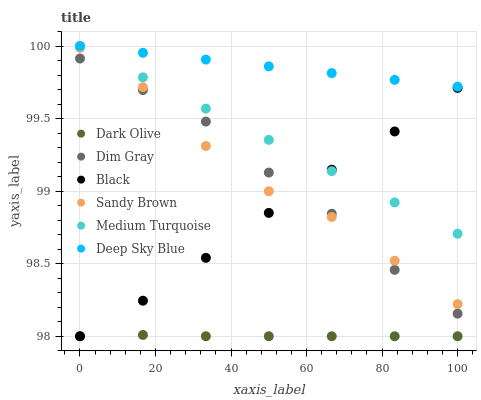Does Dark Olive have the minimum area under the curve?
Answer yes or no. Yes. Does Deep Sky Blue have the maximum area under the curve?
Answer yes or no. Yes. Does Medium Turquoise have the minimum area under the curve?
Answer yes or no. No. Does Medium Turquoise have the maximum area under the curve?
Answer yes or no. No. Is Deep Sky Blue the smoothest?
Answer yes or no. Yes. Is Sandy Brown the roughest?
Answer yes or no. Yes. Is Medium Turquoise the smoothest?
Answer yes or no. No. Is Medium Turquoise the roughest?
Answer yes or no. No. Does Dark Olive have the lowest value?
Answer yes or no. Yes. Does Medium Turquoise have the lowest value?
Answer yes or no. No. Does Deep Sky Blue have the highest value?
Answer yes or no. Yes. Does Dark Olive have the highest value?
Answer yes or no. No. Is Dark Olive less than Deep Sky Blue?
Answer yes or no. Yes. Is Deep Sky Blue greater than Black?
Answer yes or no. Yes. Does Black intersect Dark Olive?
Answer yes or no. Yes. Is Black less than Dark Olive?
Answer yes or no. No. Is Black greater than Dark Olive?
Answer yes or no. No. Does Dark Olive intersect Deep Sky Blue?
Answer yes or no. No. 